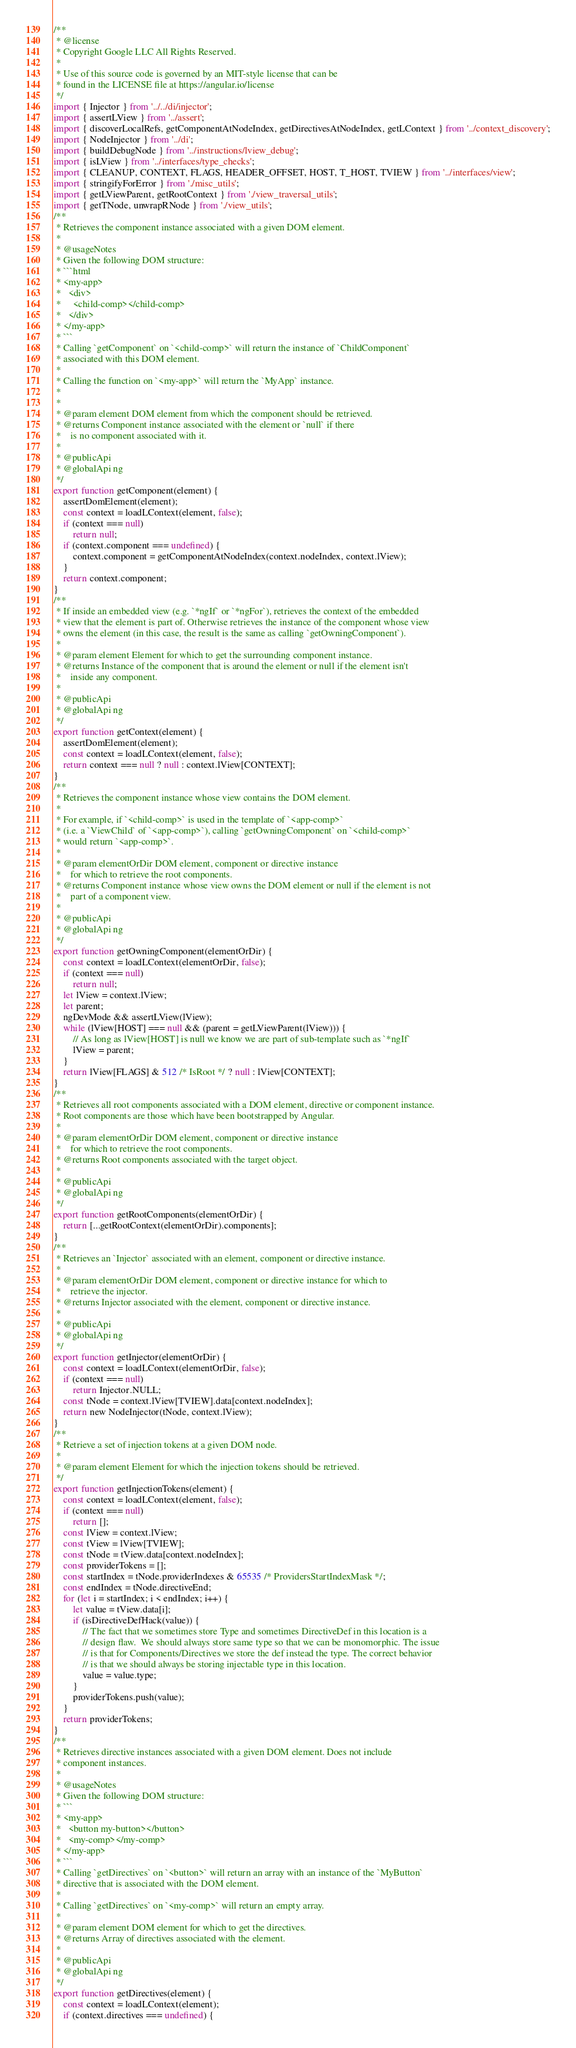<code> <loc_0><loc_0><loc_500><loc_500><_JavaScript_>/**
 * @license
 * Copyright Google LLC All Rights Reserved.
 *
 * Use of this source code is governed by an MIT-style license that can be
 * found in the LICENSE file at https://angular.io/license
 */
import { Injector } from '../../di/injector';
import { assertLView } from '../assert';
import { discoverLocalRefs, getComponentAtNodeIndex, getDirectivesAtNodeIndex, getLContext } from '../context_discovery';
import { NodeInjector } from '../di';
import { buildDebugNode } from '../instructions/lview_debug';
import { isLView } from '../interfaces/type_checks';
import { CLEANUP, CONTEXT, FLAGS, HEADER_OFFSET, HOST, T_HOST, TVIEW } from '../interfaces/view';
import { stringifyForError } from './misc_utils';
import { getLViewParent, getRootContext } from './view_traversal_utils';
import { getTNode, unwrapRNode } from './view_utils';
/**
 * Retrieves the component instance associated with a given DOM element.
 *
 * @usageNotes
 * Given the following DOM structure:
 * ```html
 * <my-app>
 *   <div>
 *     <child-comp></child-comp>
 *   </div>
 * </my-app>
 * ```
 * Calling `getComponent` on `<child-comp>` will return the instance of `ChildComponent`
 * associated with this DOM element.
 *
 * Calling the function on `<my-app>` will return the `MyApp` instance.
 *
 *
 * @param element DOM element from which the component should be retrieved.
 * @returns Component instance associated with the element or `null` if there
 *    is no component associated with it.
 *
 * @publicApi
 * @globalApi ng
 */
export function getComponent(element) {
    assertDomElement(element);
    const context = loadLContext(element, false);
    if (context === null)
        return null;
    if (context.component === undefined) {
        context.component = getComponentAtNodeIndex(context.nodeIndex, context.lView);
    }
    return context.component;
}
/**
 * If inside an embedded view (e.g. `*ngIf` or `*ngFor`), retrieves the context of the embedded
 * view that the element is part of. Otherwise retrieves the instance of the component whose view
 * owns the element (in this case, the result is the same as calling `getOwningComponent`).
 *
 * @param element Element for which to get the surrounding component instance.
 * @returns Instance of the component that is around the element or null if the element isn't
 *    inside any component.
 *
 * @publicApi
 * @globalApi ng
 */
export function getContext(element) {
    assertDomElement(element);
    const context = loadLContext(element, false);
    return context === null ? null : context.lView[CONTEXT];
}
/**
 * Retrieves the component instance whose view contains the DOM element.
 *
 * For example, if `<child-comp>` is used in the template of `<app-comp>`
 * (i.e. a `ViewChild` of `<app-comp>`), calling `getOwningComponent` on `<child-comp>`
 * would return `<app-comp>`.
 *
 * @param elementOrDir DOM element, component or directive instance
 *    for which to retrieve the root components.
 * @returns Component instance whose view owns the DOM element or null if the element is not
 *    part of a component view.
 *
 * @publicApi
 * @globalApi ng
 */
export function getOwningComponent(elementOrDir) {
    const context = loadLContext(elementOrDir, false);
    if (context === null)
        return null;
    let lView = context.lView;
    let parent;
    ngDevMode && assertLView(lView);
    while (lView[HOST] === null && (parent = getLViewParent(lView))) {
        // As long as lView[HOST] is null we know we are part of sub-template such as `*ngIf`
        lView = parent;
    }
    return lView[FLAGS] & 512 /* IsRoot */ ? null : lView[CONTEXT];
}
/**
 * Retrieves all root components associated with a DOM element, directive or component instance.
 * Root components are those which have been bootstrapped by Angular.
 *
 * @param elementOrDir DOM element, component or directive instance
 *    for which to retrieve the root components.
 * @returns Root components associated with the target object.
 *
 * @publicApi
 * @globalApi ng
 */
export function getRootComponents(elementOrDir) {
    return [...getRootContext(elementOrDir).components];
}
/**
 * Retrieves an `Injector` associated with an element, component or directive instance.
 *
 * @param elementOrDir DOM element, component or directive instance for which to
 *    retrieve the injector.
 * @returns Injector associated with the element, component or directive instance.
 *
 * @publicApi
 * @globalApi ng
 */
export function getInjector(elementOrDir) {
    const context = loadLContext(elementOrDir, false);
    if (context === null)
        return Injector.NULL;
    const tNode = context.lView[TVIEW].data[context.nodeIndex];
    return new NodeInjector(tNode, context.lView);
}
/**
 * Retrieve a set of injection tokens at a given DOM node.
 *
 * @param element Element for which the injection tokens should be retrieved.
 */
export function getInjectionTokens(element) {
    const context = loadLContext(element, false);
    if (context === null)
        return [];
    const lView = context.lView;
    const tView = lView[TVIEW];
    const tNode = tView.data[context.nodeIndex];
    const providerTokens = [];
    const startIndex = tNode.providerIndexes & 65535 /* ProvidersStartIndexMask */;
    const endIndex = tNode.directiveEnd;
    for (let i = startIndex; i < endIndex; i++) {
        let value = tView.data[i];
        if (isDirectiveDefHack(value)) {
            // The fact that we sometimes store Type and sometimes DirectiveDef in this location is a
            // design flaw.  We should always store same type so that we can be monomorphic. The issue
            // is that for Components/Directives we store the def instead the type. The correct behavior
            // is that we should always be storing injectable type in this location.
            value = value.type;
        }
        providerTokens.push(value);
    }
    return providerTokens;
}
/**
 * Retrieves directive instances associated with a given DOM element. Does not include
 * component instances.
 *
 * @usageNotes
 * Given the following DOM structure:
 * ```
 * <my-app>
 *   <button my-button></button>
 *   <my-comp></my-comp>
 * </my-app>
 * ```
 * Calling `getDirectives` on `<button>` will return an array with an instance of the `MyButton`
 * directive that is associated with the DOM element.
 *
 * Calling `getDirectives` on `<my-comp>` will return an empty array.
 *
 * @param element DOM element for which to get the directives.
 * @returns Array of directives associated with the element.
 *
 * @publicApi
 * @globalApi ng
 */
export function getDirectives(element) {
    const context = loadLContext(element);
    if (context.directives === undefined) {</code> 